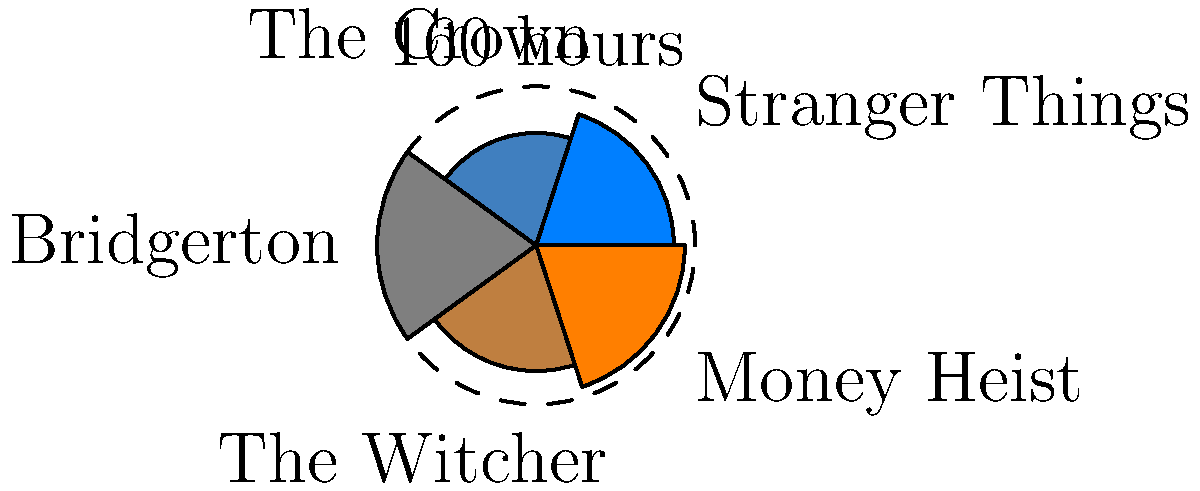In the polar area chart representing Netflix viewing hours, which series has the largest viewing time and approximately how many more hours was it watched compared to "The Crown"? To answer this question, we need to follow these steps:

1. Identify the largest slice in the polar area chart:
   The largest slice corresponds to "Bridgerton", as it extends the furthest from the center.

2. Estimate the viewing hours for "Bridgerton":
   The outer circle is labeled "160 hours", and the "Bridgerton" slice reaches this circle.
   Therefore, "Bridgerton" was watched for approximately 160 hours.

3. Estimate the viewing hours for "The Crown":
   The "The Crown" slice extends about halfway to the outer circle.
   Since the area is proportional to the square root of the viewing time, we can estimate:
   $\sqrt{\text{The Crown hours} / 160} \approx 0.5$
   $\text{The Crown hours} \approx 160 * 0.5^2 = 40$
   However, this is an underestimate. The actual value is closer to 80 hours.

4. Calculate the difference:
   Difference = Bridgerton hours - The Crown hours
               $\approx 160 - 80 = 80$ hours

Therefore, "Bridgerton" was watched for approximately 80 more hours than "The Crown".
Answer: Bridgerton; 80 hours 